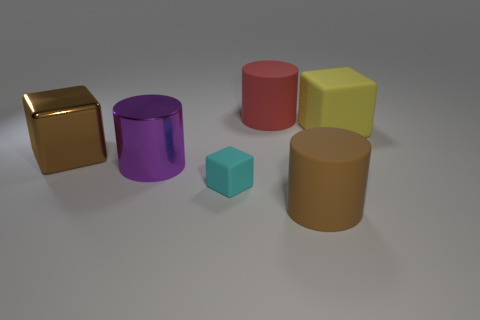Does the object that is left of the purple metallic thing have the same size as the cyan matte thing?
Provide a short and direct response. No. How many other things are there of the same material as the large brown cube?
Provide a succinct answer. 1. How many gray things are either large cylinders or rubber cylinders?
Provide a succinct answer. 0. What number of large matte cylinders are in front of the red object?
Provide a short and direct response. 1. How big is the rubber object that is on the left side of the large matte cylinder that is behind the cylinder that is in front of the purple metal cylinder?
Keep it short and to the point. Small. There is a brown thing on the right side of the cyan block that is in front of the red rubber cylinder; is there a brown cylinder behind it?
Keep it short and to the point. No. Is the number of big purple metal things greater than the number of big cyan rubber cylinders?
Make the answer very short. Yes. What is the color of the matte cylinder that is to the right of the big red object?
Provide a short and direct response. Brown. Is the number of small cyan objects in front of the purple object greater than the number of small red matte objects?
Offer a terse response. Yes. Is the red cylinder made of the same material as the tiny cyan object?
Offer a very short reply. Yes. 